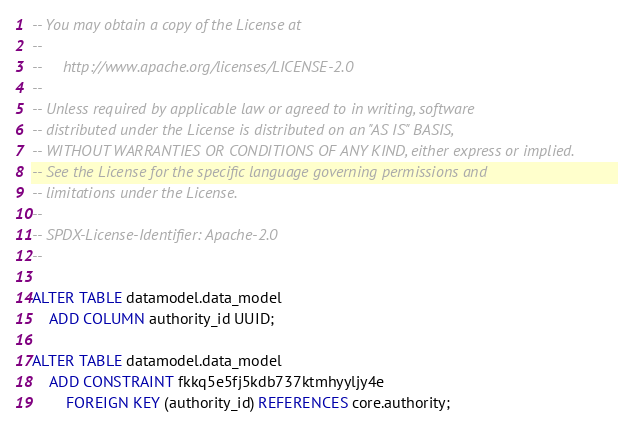<code> <loc_0><loc_0><loc_500><loc_500><_SQL_>-- You may obtain a copy of the License at
--
--     http://www.apache.org/licenses/LICENSE-2.0
--
-- Unless required by applicable law or agreed to in writing, software
-- distributed under the License is distributed on an "AS IS" BASIS,
-- WITHOUT WARRANTIES OR CONDITIONS OF ANY KIND, either express or implied.
-- See the License for the specific language governing permissions and
-- limitations under the License.
--
-- SPDX-License-Identifier: Apache-2.0
--

ALTER TABLE datamodel.data_model
    ADD COLUMN authority_id UUID;

ALTER TABLE datamodel.data_model
    ADD CONSTRAINT fkkq5e5fj5kdb737ktmhyyljy4e
        FOREIGN KEY (authority_id) REFERENCES core.authority;

</code> 